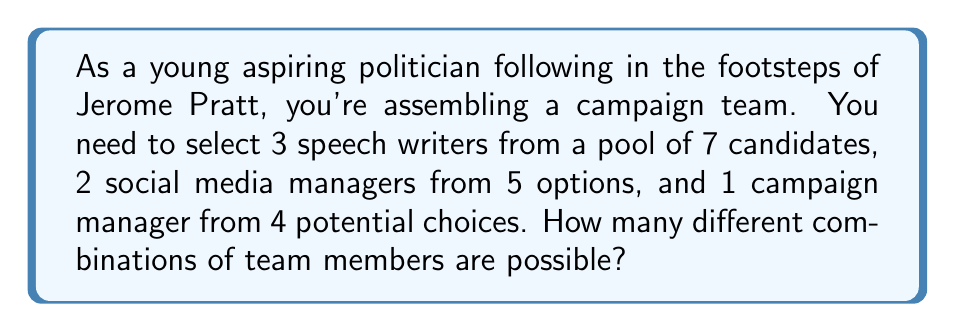Could you help me with this problem? Let's break this down step-by-step:

1) For the speech writers:
   We need to choose 3 out of 7 candidates. This is a combination problem, represented as $\binom{7}{3}$.
   $$\binom{7}{3} = \frac{7!}{3!(7-3)!} = \frac{7!}{3!4!} = 35$$

2) For the social media managers:
   We need to choose 2 out of 5 options. This is represented as $\binom{5}{2}$.
   $$\binom{5}{2} = \frac{5!}{2!(5-2)!} = \frac{5!}{2!3!} = 10$$

3) For the campaign manager:
   We need to choose 1 out of 4 choices. This is simply $\binom{4}{1} = 4$.

4) Now, according to the Multiplication Principle, if we have $m$ ways of doing something, $n$ ways of doing another thing, and $p$ ways of doing a third thing, then there are $m \times n \times p$ ways to do all three things.

5) Therefore, the total number of possible combinations is:
   $$35 \times 10 \times 4 = 1,400$$
Answer: 1,400 